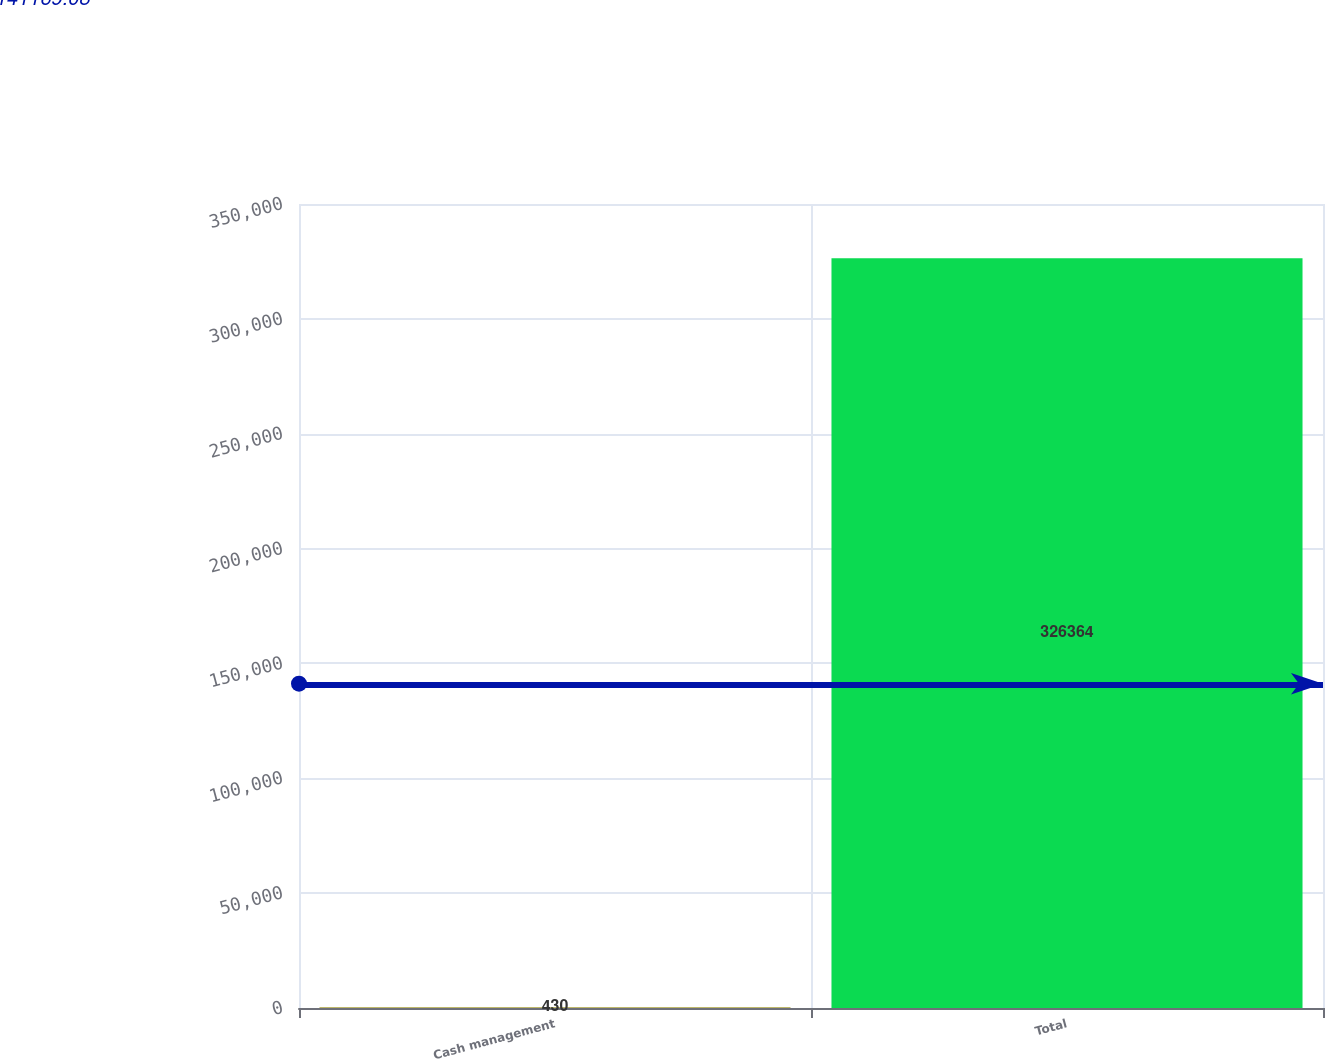<chart> <loc_0><loc_0><loc_500><loc_500><bar_chart><fcel>Cash management<fcel>Total<nl><fcel>430<fcel>326364<nl></chart> 